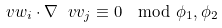<formula> <loc_0><loc_0><loc_500><loc_500>\ v w _ { i } \cdot \nabla \ v v _ { j } \equiv 0 \mod \phi _ { 1 } , \phi _ { 2 }</formula> 